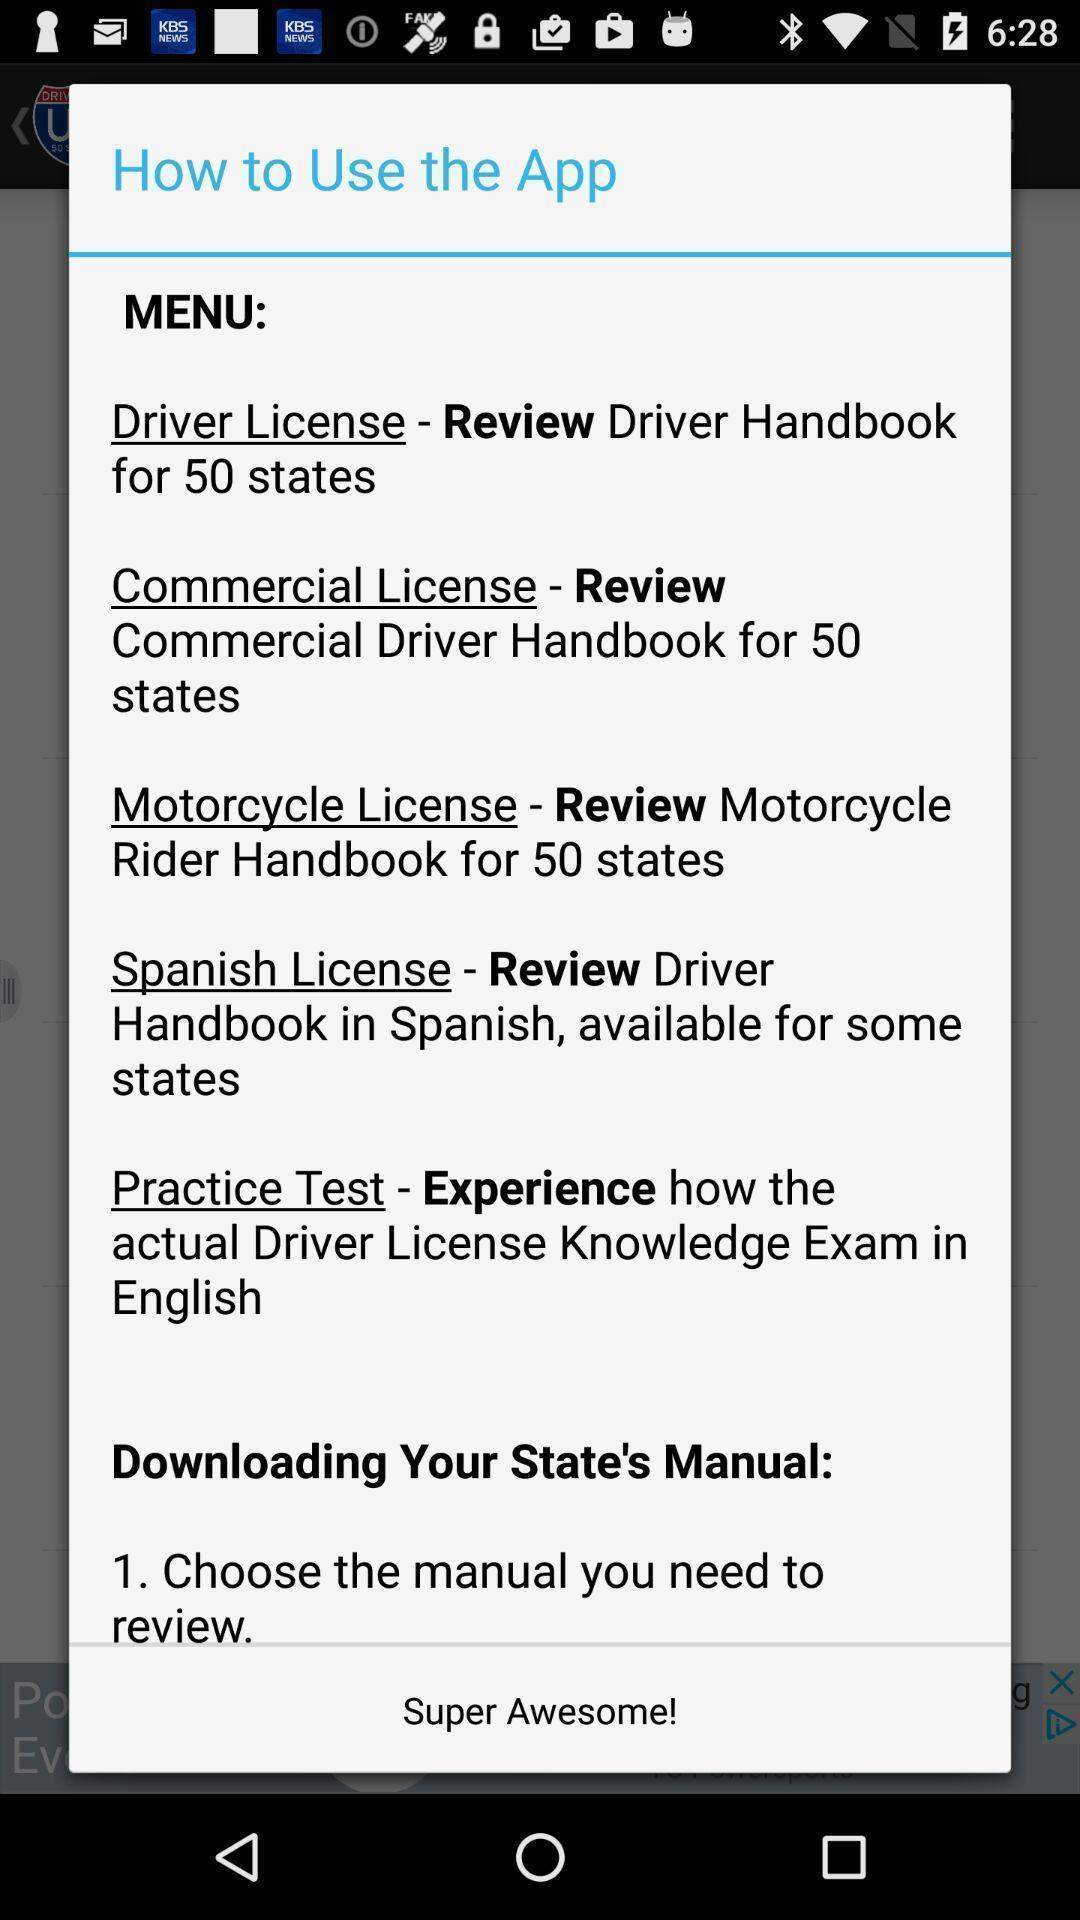Give me a narrative description of this picture. Pop-up showing list of instructions to use the app. 